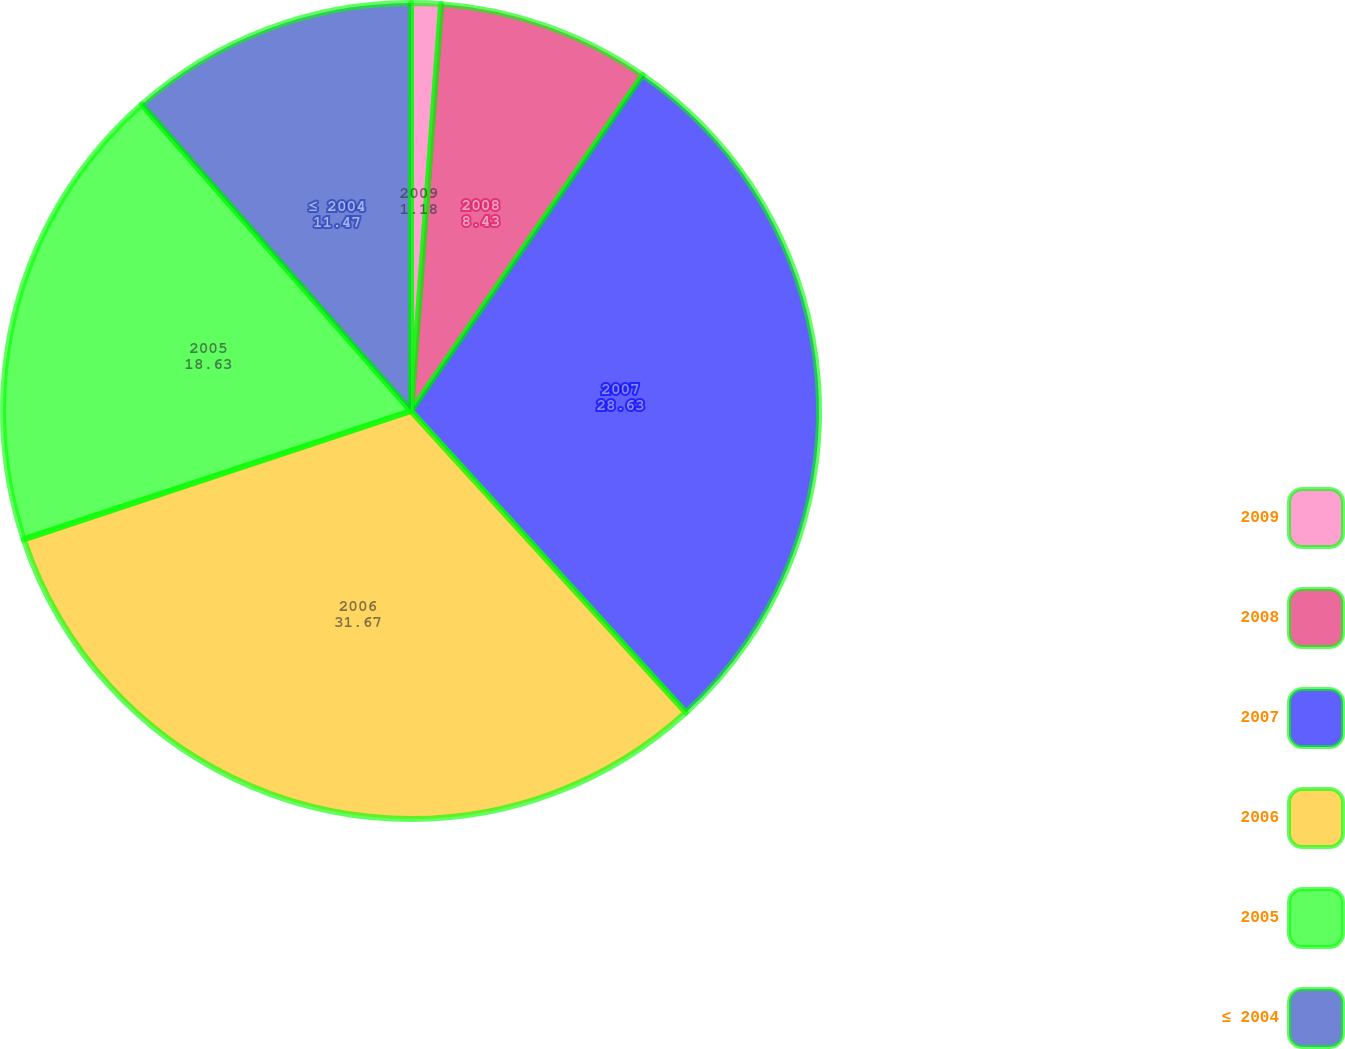Convert chart to OTSL. <chart><loc_0><loc_0><loc_500><loc_500><pie_chart><fcel>2009<fcel>2008<fcel>2007<fcel>2006<fcel>2005<fcel>≤ 2004<nl><fcel>1.18%<fcel>8.43%<fcel>28.63%<fcel>31.67%<fcel>18.63%<fcel>11.47%<nl></chart> 